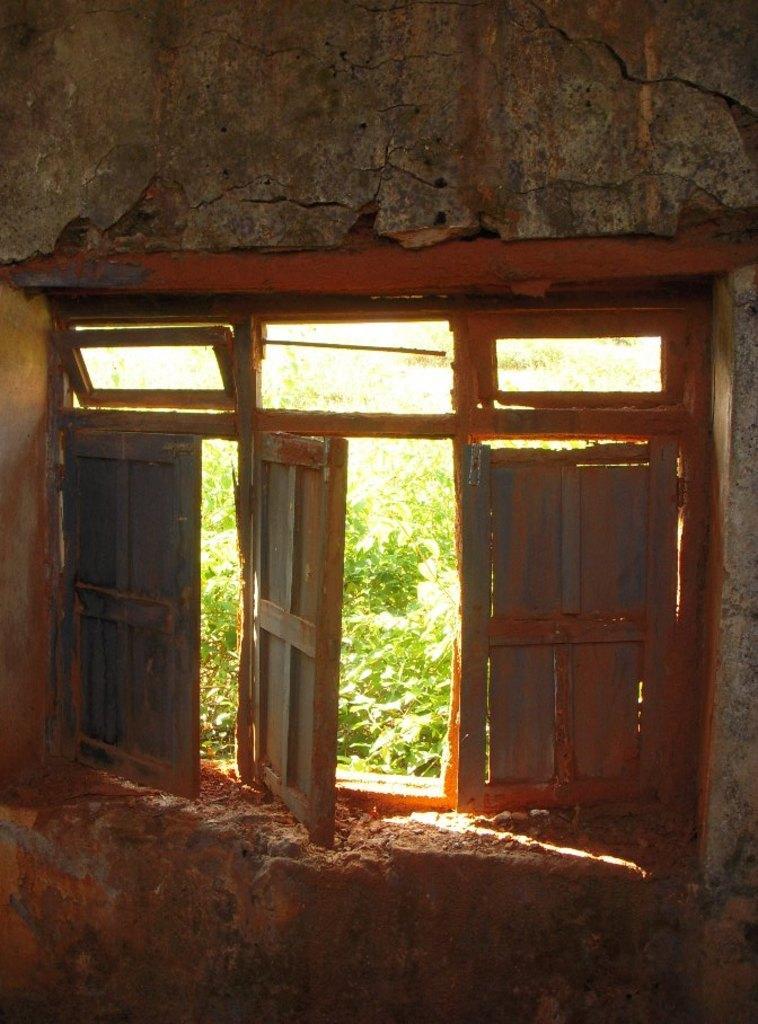In one or two sentences, can you explain what this image depicts? In this image I can see a window to a wall. In the outside there are some plants. 